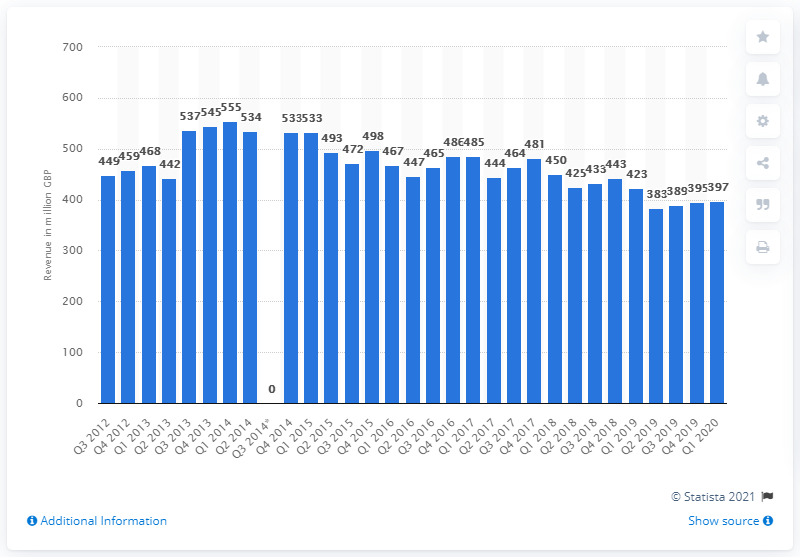Mention a couple of crucial points in this snapshot. During the first quarter of 2020, the revenue generated from office equipment and consumables was 397 million dollars. 